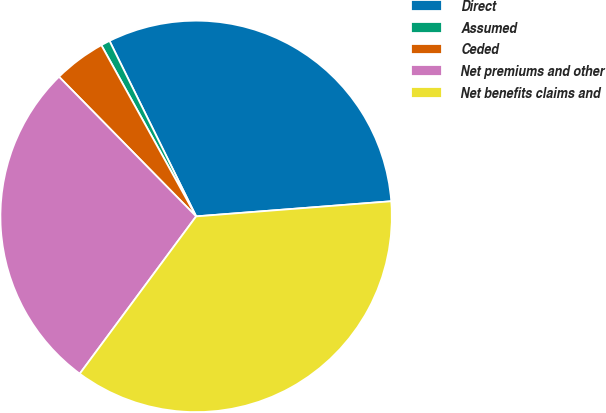Convert chart to OTSL. <chart><loc_0><loc_0><loc_500><loc_500><pie_chart><fcel>Direct<fcel>Assumed<fcel>Ceded<fcel>Net premiums and other<fcel>Net benefits claims and<nl><fcel>31.07%<fcel>0.75%<fcel>4.31%<fcel>27.51%<fcel>36.37%<nl></chart> 